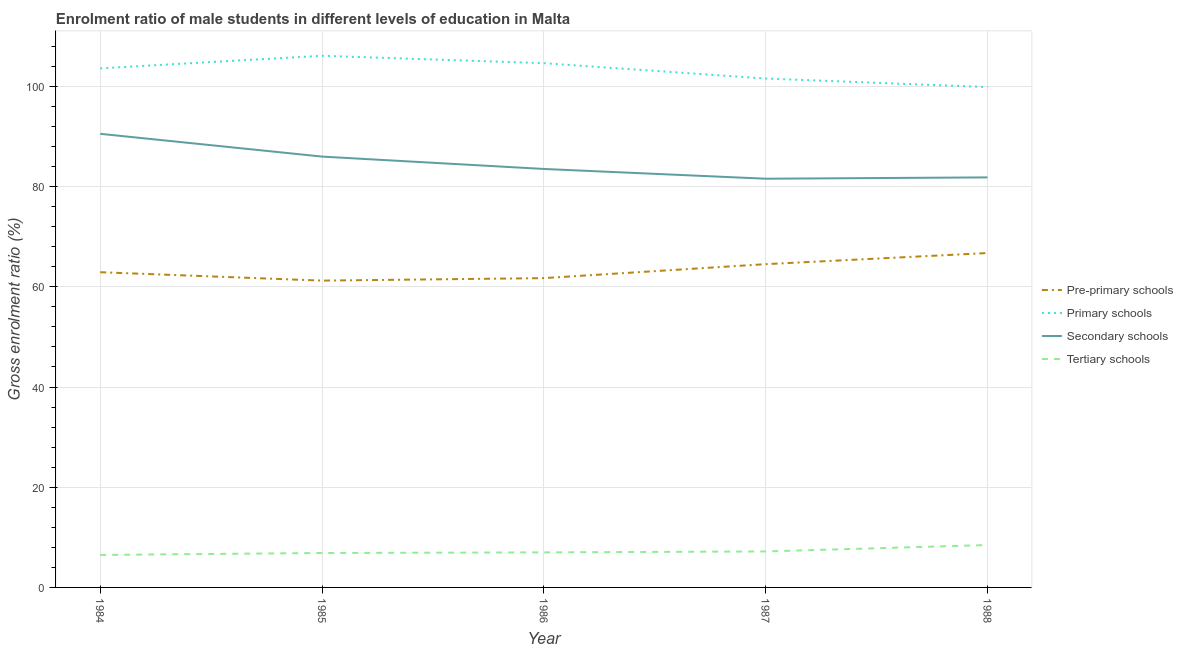How many different coloured lines are there?
Give a very brief answer. 4. Is the number of lines equal to the number of legend labels?
Give a very brief answer. Yes. What is the gross enrolment ratio(female) in pre-primary schools in 1986?
Offer a terse response. 61.73. Across all years, what is the maximum gross enrolment ratio(female) in primary schools?
Provide a succinct answer. 106.1. Across all years, what is the minimum gross enrolment ratio(female) in primary schools?
Give a very brief answer. 99.86. In which year was the gross enrolment ratio(female) in tertiary schools maximum?
Your answer should be very brief. 1988. What is the total gross enrolment ratio(female) in primary schools in the graph?
Ensure brevity in your answer.  515.75. What is the difference between the gross enrolment ratio(female) in pre-primary schools in 1986 and that in 1987?
Offer a very short reply. -2.79. What is the difference between the gross enrolment ratio(female) in tertiary schools in 1985 and the gross enrolment ratio(female) in secondary schools in 1987?
Keep it short and to the point. -74.7. What is the average gross enrolment ratio(female) in pre-primary schools per year?
Provide a short and direct response. 63.43. In the year 1986, what is the difference between the gross enrolment ratio(female) in secondary schools and gross enrolment ratio(female) in tertiary schools?
Offer a very short reply. 76.52. In how many years, is the gross enrolment ratio(female) in secondary schools greater than 4 %?
Ensure brevity in your answer.  5. What is the ratio of the gross enrolment ratio(female) in tertiary schools in 1986 to that in 1987?
Keep it short and to the point. 0.97. Is the gross enrolment ratio(female) in primary schools in 1984 less than that in 1986?
Your answer should be very brief. Yes. Is the difference between the gross enrolment ratio(female) in primary schools in 1986 and 1987 greater than the difference between the gross enrolment ratio(female) in secondary schools in 1986 and 1987?
Your answer should be compact. Yes. What is the difference between the highest and the second highest gross enrolment ratio(female) in primary schools?
Your answer should be compact. 1.48. What is the difference between the highest and the lowest gross enrolment ratio(female) in pre-primary schools?
Offer a terse response. 5.51. Is it the case that in every year, the sum of the gross enrolment ratio(female) in tertiary schools and gross enrolment ratio(female) in secondary schools is greater than the sum of gross enrolment ratio(female) in primary schools and gross enrolment ratio(female) in pre-primary schools?
Offer a terse response. No. Is it the case that in every year, the sum of the gross enrolment ratio(female) in pre-primary schools and gross enrolment ratio(female) in primary schools is greater than the gross enrolment ratio(female) in secondary schools?
Your answer should be very brief. Yes. Does the gross enrolment ratio(female) in tertiary schools monotonically increase over the years?
Provide a succinct answer. Yes. Is the gross enrolment ratio(female) in pre-primary schools strictly less than the gross enrolment ratio(female) in primary schools over the years?
Provide a succinct answer. Yes. How many lines are there?
Make the answer very short. 4. How many years are there in the graph?
Provide a short and direct response. 5. Does the graph contain any zero values?
Your response must be concise. No. Does the graph contain grids?
Ensure brevity in your answer.  Yes. Where does the legend appear in the graph?
Give a very brief answer. Center right. How are the legend labels stacked?
Your answer should be very brief. Vertical. What is the title of the graph?
Give a very brief answer. Enrolment ratio of male students in different levels of education in Malta. Does "Management rating" appear as one of the legend labels in the graph?
Ensure brevity in your answer.  No. What is the label or title of the Y-axis?
Make the answer very short. Gross enrolment ratio (%). What is the Gross enrolment ratio (%) in Pre-primary schools in 1984?
Your answer should be compact. 62.91. What is the Gross enrolment ratio (%) of Primary schools in 1984?
Keep it short and to the point. 103.6. What is the Gross enrolment ratio (%) of Secondary schools in 1984?
Offer a terse response. 90.53. What is the Gross enrolment ratio (%) of Tertiary schools in 1984?
Your response must be concise. 6.48. What is the Gross enrolment ratio (%) in Pre-primary schools in 1985?
Provide a succinct answer. 61.23. What is the Gross enrolment ratio (%) in Primary schools in 1985?
Keep it short and to the point. 106.1. What is the Gross enrolment ratio (%) in Secondary schools in 1985?
Offer a very short reply. 85.99. What is the Gross enrolment ratio (%) of Tertiary schools in 1985?
Provide a succinct answer. 6.87. What is the Gross enrolment ratio (%) of Pre-primary schools in 1986?
Ensure brevity in your answer.  61.73. What is the Gross enrolment ratio (%) in Primary schools in 1986?
Offer a terse response. 104.63. What is the Gross enrolment ratio (%) of Secondary schools in 1986?
Offer a very short reply. 83.52. What is the Gross enrolment ratio (%) of Tertiary schools in 1986?
Offer a terse response. 6.99. What is the Gross enrolment ratio (%) in Pre-primary schools in 1987?
Keep it short and to the point. 64.52. What is the Gross enrolment ratio (%) of Primary schools in 1987?
Provide a succinct answer. 101.56. What is the Gross enrolment ratio (%) of Secondary schools in 1987?
Keep it short and to the point. 81.57. What is the Gross enrolment ratio (%) of Tertiary schools in 1987?
Keep it short and to the point. 7.18. What is the Gross enrolment ratio (%) of Pre-primary schools in 1988?
Provide a succinct answer. 66.74. What is the Gross enrolment ratio (%) of Primary schools in 1988?
Give a very brief answer. 99.86. What is the Gross enrolment ratio (%) of Secondary schools in 1988?
Make the answer very short. 81.83. What is the Gross enrolment ratio (%) of Tertiary schools in 1988?
Your response must be concise. 8.46. Across all years, what is the maximum Gross enrolment ratio (%) of Pre-primary schools?
Keep it short and to the point. 66.74. Across all years, what is the maximum Gross enrolment ratio (%) of Primary schools?
Ensure brevity in your answer.  106.1. Across all years, what is the maximum Gross enrolment ratio (%) of Secondary schools?
Give a very brief answer. 90.53. Across all years, what is the maximum Gross enrolment ratio (%) of Tertiary schools?
Keep it short and to the point. 8.46. Across all years, what is the minimum Gross enrolment ratio (%) of Pre-primary schools?
Provide a succinct answer. 61.23. Across all years, what is the minimum Gross enrolment ratio (%) of Primary schools?
Your answer should be compact. 99.86. Across all years, what is the minimum Gross enrolment ratio (%) of Secondary schools?
Your answer should be very brief. 81.57. Across all years, what is the minimum Gross enrolment ratio (%) in Tertiary schools?
Keep it short and to the point. 6.48. What is the total Gross enrolment ratio (%) of Pre-primary schools in the graph?
Your answer should be very brief. 317.13. What is the total Gross enrolment ratio (%) in Primary schools in the graph?
Offer a terse response. 515.75. What is the total Gross enrolment ratio (%) of Secondary schools in the graph?
Give a very brief answer. 423.43. What is the total Gross enrolment ratio (%) in Tertiary schools in the graph?
Your answer should be very brief. 36. What is the difference between the Gross enrolment ratio (%) of Pre-primary schools in 1984 and that in 1985?
Your answer should be very brief. 1.68. What is the difference between the Gross enrolment ratio (%) in Primary schools in 1984 and that in 1985?
Offer a very short reply. -2.51. What is the difference between the Gross enrolment ratio (%) in Secondary schools in 1984 and that in 1985?
Offer a very short reply. 4.54. What is the difference between the Gross enrolment ratio (%) in Tertiary schools in 1984 and that in 1985?
Ensure brevity in your answer.  -0.39. What is the difference between the Gross enrolment ratio (%) of Pre-primary schools in 1984 and that in 1986?
Make the answer very short. 1.18. What is the difference between the Gross enrolment ratio (%) of Primary schools in 1984 and that in 1986?
Offer a terse response. -1.03. What is the difference between the Gross enrolment ratio (%) in Secondary schools in 1984 and that in 1986?
Offer a terse response. 7.01. What is the difference between the Gross enrolment ratio (%) of Tertiary schools in 1984 and that in 1986?
Your response must be concise. -0.51. What is the difference between the Gross enrolment ratio (%) in Pre-primary schools in 1984 and that in 1987?
Your response must be concise. -1.61. What is the difference between the Gross enrolment ratio (%) of Primary schools in 1984 and that in 1987?
Your answer should be compact. 2.04. What is the difference between the Gross enrolment ratio (%) in Secondary schools in 1984 and that in 1987?
Your answer should be very brief. 8.96. What is the difference between the Gross enrolment ratio (%) in Tertiary schools in 1984 and that in 1987?
Give a very brief answer. -0.7. What is the difference between the Gross enrolment ratio (%) in Pre-primary schools in 1984 and that in 1988?
Give a very brief answer. -3.83. What is the difference between the Gross enrolment ratio (%) in Primary schools in 1984 and that in 1988?
Your response must be concise. 3.74. What is the difference between the Gross enrolment ratio (%) in Secondary schools in 1984 and that in 1988?
Give a very brief answer. 8.7. What is the difference between the Gross enrolment ratio (%) of Tertiary schools in 1984 and that in 1988?
Your answer should be compact. -1.98. What is the difference between the Gross enrolment ratio (%) in Pre-primary schools in 1985 and that in 1986?
Provide a short and direct response. -0.5. What is the difference between the Gross enrolment ratio (%) in Primary schools in 1985 and that in 1986?
Ensure brevity in your answer.  1.48. What is the difference between the Gross enrolment ratio (%) in Secondary schools in 1985 and that in 1986?
Keep it short and to the point. 2.47. What is the difference between the Gross enrolment ratio (%) in Tertiary schools in 1985 and that in 1986?
Your answer should be very brief. -0.12. What is the difference between the Gross enrolment ratio (%) in Pre-primary schools in 1985 and that in 1987?
Ensure brevity in your answer.  -3.28. What is the difference between the Gross enrolment ratio (%) in Primary schools in 1985 and that in 1987?
Offer a very short reply. 4.54. What is the difference between the Gross enrolment ratio (%) in Secondary schools in 1985 and that in 1987?
Ensure brevity in your answer.  4.42. What is the difference between the Gross enrolment ratio (%) of Tertiary schools in 1985 and that in 1987?
Ensure brevity in your answer.  -0.31. What is the difference between the Gross enrolment ratio (%) in Pre-primary schools in 1985 and that in 1988?
Offer a terse response. -5.51. What is the difference between the Gross enrolment ratio (%) in Primary schools in 1985 and that in 1988?
Offer a terse response. 6.24. What is the difference between the Gross enrolment ratio (%) in Secondary schools in 1985 and that in 1988?
Make the answer very short. 4.15. What is the difference between the Gross enrolment ratio (%) in Tertiary schools in 1985 and that in 1988?
Ensure brevity in your answer.  -1.59. What is the difference between the Gross enrolment ratio (%) of Pre-primary schools in 1986 and that in 1987?
Provide a short and direct response. -2.79. What is the difference between the Gross enrolment ratio (%) in Primary schools in 1986 and that in 1987?
Keep it short and to the point. 3.07. What is the difference between the Gross enrolment ratio (%) in Secondary schools in 1986 and that in 1987?
Your answer should be very brief. 1.95. What is the difference between the Gross enrolment ratio (%) in Tertiary schools in 1986 and that in 1987?
Ensure brevity in your answer.  -0.19. What is the difference between the Gross enrolment ratio (%) of Pre-primary schools in 1986 and that in 1988?
Your response must be concise. -5.01. What is the difference between the Gross enrolment ratio (%) of Primary schools in 1986 and that in 1988?
Your answer should be very brief. 4.77. What is the difference between the Gross enrolment ratio (%) in Secondary schools in 1986 and that in 1988?
Offer a very short reply. 1.68. What is the difference between the Gross enrolment ratio (%) of Tertiary schools in 1986 and that in 1988?
Offer a very short reply. -1.47. What is the difference between the Gross enrolment ratio (%) of Pre-primary schools in 1987 and that in 1988?
Your answer should be very brief. -2.22. What is the difference between the Gross enrolment ratio (%) of Primary schools in 1987 and that in 1988?
Provide a short and direct response. 1.7. What is the difference between the Gross enrolment ratio (%) in Secondary schools in 1987 and that in 1988?
Keep it short and to the point. -0.26. What is the difference between the Gross enrolment ratio (%) of Tertiary schools in 1987 and that in 1988?
Offer a terse response. -1.28. What is the difference between the Gross enrolment ratio (%) of Pre-primary schools in 1984 and the Gross enrolment ratio (%) of Primary schools in 1985?
Ensure brevity in your answer.  -43.19. What is the difference between the Gross enrolment ratio (%) of Pre-primary schools in 1984 and the Gross enrolment ratio (%) of Secondary schools in 1985?
Offer a very short reply. -23.08. What is the difference between the Gross enrolment ratio (%) in Pre-primary schools in 1984 and the Gross enrolment ratio (%) in Tertiary schools in 1985?
Offer a terse response. 56.04. What is the difference between the Gross enrolment ratio (%) in Primary schools in 1984 and the Gross enrolment ratio (%) in Secondary schools in 1985?
Offer a very short reply. 17.61. What is the difference between the Gross enrolment ratio (%) in Primary schools in 1984 and the Gross enrolment ratio (%) in Tertiary schools in 1985?
Provide a succinct answer. 96.72. What is the difference between the Gross enrolment ratio (%) in Secondary schools in 1984 and the Gross enrolment ratio (%) in Tertiary schools in 1985?
Ensure brevity in your answer.  83.66. What is the difference between the Gross enrolment ratio (%) of Pre-primary schools in 1984 and the Gross enrolment ratio (%) of Primary schools in 1986?
Make the answer very short. -41.72. What is the difference between the Gross enrolment ratio (%) in Pre-primary schools in 1984 and the Gross enrolment ratio (%) in Secondary schools in 1986?
Provide a short and direct response. -20.61. What is the difference between the Gross enrolment ratio (%) of Pre-primary schools in 1984 and the Gross enrolment ratio (%) of Tertiary schools in 1986?
Offer a terse response. 55.91. What is the difference between the Gross enrolment ratio (%) in Primary schools in 1984 and the Gross enrolment ratio (%) in Secondary schools in 1986?
Give a very brief answer. 20.08. What is the difference between the Gross enrolment ratio (%) of Primary schools in 1984 and the Gross enrolment ratio (%) of Tertiary schools in 1986?
Your response must be concise. 96.6. What is the difference between the Gross enrolment ratio (%) in Secondary schools in 1984 and the Gross enrolment ratio (%) in Tertiary schools in 1986?
Give a very brief answer. 83.54. What is the difference between the Gross enrolment ratio (%) of Pre-primary schools in 1984 and the Gross enrolment ratio (%) of Primary schools in 1987?
Give a very brief answer. -38.65. What is the difference between the Gross enrolment ratio (%) of Pre-primary schools in 1984 and the Gross enrolment ratio (%) of Secondary schools in 1987?
Offer a very short reply. -18.66. What is the difference between the Gross enrolment ratio (%) of Pre-primary schools in 1984 and the Gross enrolment ratio (%) of Tertiary schools in 1987?
Provide a short and direct response. 55.73. What is the difference between the Gross enrolment ratio (%) in Primary schools in 1984 and the Gross enrolment ratio (%) in Secondary schools in 1987?
Provide a succinct answer. 22.03. What is the difference between the Gross enrolment ratio (%) of Primary schools in 1984 and the Gross enrolment ratio (%) of Tertiary schools in 1987?
Ensure brevity in your answer.  96.42. What is the difference between the Gross enrolment ratio (%) in Secondary schools in 1984 and the Gross enrolment ratio (%) in Tertiary schools in 1987?
Ensure brevity in your answer.  83.35. What is the difference between the Gross enrolment ratio (%) of Pre-primary schools in 1984 and the Gross enrolment ratio (%) of Primary schools in 1988?
Offer a very short reply. -36.95. What is the difference between the Gross enrolment ratio (%) in Pre-primary schools in 1984 and the Gross enrolment ratio (%) in Secondary schools in 1988?
Make the answer very short. -18.93. What is the difference between the Gross enrolment ratio (%) in Pre-primary schools in 1984 and the Gross enrolment ratio (%) in Tertiary schools in 1988?
Provide a succinct answer. 54.45. What is the difference between the Gross enrolment ratio (%) in Primary schools in 1984 and the Gross enrolment ratio (%) in Secondary schools in 1988?
Ensure brevity in your answer.  21.76. What is the difference between the Gross enrolment ratio (%) in Primary schools in 1984 and the Gross enrolment ratio (%) in Tertiary schools in 1988?
Your answer should be compact. 95.14. What is the difference between the Gross enrolment ratio (%) in Secondary schools in 1984 and the Gross enrolment ratio (%) in Tertiary schools in 1988?
Provide a succinct answer. 82.07. What is the difference between the Gross enrolment ratio (%) of Pre-primary schools in 1985 and the Gross enrolment ratio (%) of Primary schools in 1986?
Keep it short and to the point. -43.39. What is the difference between the Gross enrolment ratio (%) in Pre-primary schools in 1985 and the Gross enrolment ratio (%) in Secondary schools in 1986?
Your response must be concise. -22.28. What is the difference between the Gross enrolment ratio (%) in Pre-primary schools in 1985 and the Gross enrolment ratio (%) in Tertiary schools in 1986?
Your answer should be compact. 54.24. What is the difference between the Gross enrolment ratio (%) in Primary schools in 1985 and the Gross enrolment ratio (%) in Secondary schools in 1986?
Give a very brief answer. 22.59. What is the difference between the Gross enrolment ratio (%) of Primary schools in 1985 and the Gross enrolment ratio (%) of Tertiary schools in 1986?
Provide a short and direct response. 99.11. What is the difference between the Gross enrolment ratio (%) in Secondary schools in 1985 and the Gross enrolment ratio (%) in Tertiary schools in 1986?
Ensure brevity in your answer.  78.99. What is the difference between the Gross enrolment ratio (%) of Pre-primary schools in 1985 and the Gross enrolment ratio (%) of Primary schools in 1987?
Offer a terse response. -40.33. What is the difference between the Gross enrolment ratio (%) of Pre-primary schools in 1985 and the Gross enrolment ratio (%) of Secondary schools in 1987?
Keep it short and to the point. -20.34. What is the difference between the Gross enrolment ratio (%) of Pre-primary schools in 1985 and the Gross enrolment ratio (%) of Tertiary schools in 1987?
Your answer should be compact. 54.05. What is the difference between the Gross enrolment ratio (%) in Primary schools in 1985 and the Gross enrolment ratio (%) in Secondary schools in 1987?
Give a very brief answer. 24.53. What is the difference between the Gross enrolment ratio (%) in Primary schools in 1985 and the Gross enrolment ratio (%) in Tertiary schools in 1987?
Your answer should be compact. 98.92. What is the difference between the Gross enrolment ratio (%) in Secondary schools in 1985 and the Gross enrolment ratio (%) in Tertiary schools in 1987?
Give a very brief answer. 78.8. What is the difference between the Gross enrolment ratio (%) of Pre-primary schools in 1985 and the Gross enrolment ratio (%) of Primary schools in 1988?
Offer a very short reply. -38.63. What is the difference between the Gross enrolment ratio (%) in Pre-primary schools in 1985 and the Gross enrolment ratio (%) in Secondary schools in 1988?
Offer a very short reply. -20.6. What is the difference between the Gross enrolment ratio (%) in Pre-primary schools in 1985 and the Gross enrolment ratio (%) in Tertiary schools in 1988?
Your answer should be very brief. 52.77. What is the difference between the Gross enrolment ratio (%) in Primary schools in 1985 and the Gross enrolment ratio (%) in Secondary schools in 1988?
Keep it short and to the point. 24.27. What is the difference between the Gross enrolment ratio (%) in Primary schools in 1985 and the Gross enrolment ratio (%) in Tertiary schools in 1988?
Ensure brevity in your answer.  97.64. What is the difference between the Gross enrolment ratio (%) in Secondary schools in 1985 and the Gross enrolment ratio (%) in Tertiary schools in 1988?
Keep it short and to the point. 77.52. What is the difference between the Gross enrolment ratio (%) in Pre-primary schools in 1986 and the Gross enrolment ratio (%) in Primary schools in 1987?
Provide a short and direct response. -39.83. What is the difference between the Gross enrolment ratio (%) in Pre-primary schools in 1986 and the Gross enrolment ratio (%) in Secondary schools in 1987?
Provide a short and direct response. -19.84. What is the difference between the Gross enrolment ratio (%) in Pre-primary schools in 1986 and the Gross enrolment ratio (%) in Tertiary schools in 1987?
Your answer should be compact. 54.55. What is the difference between the Gross enrolment ratio (%) in Primary schools in 1986 and the Gross enrolment ratio (%) in Secondary schools in 1987?
Ensure brevity in your answer.  23.06. What is the difference between the Gross enrolment ratio (%) of Primary schools in 1986 and the Gross enrolment ratio (%) of Tertiary schools in 1987?
Your answer should be compact. 97.44. What is the difference between the Gross enrolment ratio (%) in Secondary schools in 1986 and the Gross enrolment ratio (%) in Tertiary schools in 1987?
Make the answer very short. 76.33. What is the difference between the Gross enrolment ratio (%) of Pre-primary schools in 1986 and the Gross enrolment ratio (%) of Primary schools in 1988?
Provide a succinct answer. -38.13. What is the difference between the Gross enrolment ratio (%) of Pre-primary schools in 1986 and the Gross enrolment ratio (%) of Secondary schools in 1988?
Provide a succinct answer. -20.1. What is the difference between the Gross enrolment ratio (%) in Pre-primary schools in 1986 and the Gross enrolment ratio (%) in Tertiary schools in 1988?
Make the answer very short. 53.27. What is the difference between the Gross enrolment ratio (%) in Primary schools in 1986 and the Gross enrolment ratio (%) in Secondary schools in 1988?
Offer a very short reply. 22.79. What is the difference between the Gross enrolment ratio (%) of Primary schools in 1986 and the Gross enrolment ratio (%) of Tertiary schools in 1988?
Provide a succinct answer. 96.16. What is the difference between the Gross enrolment ratio (%) in Secondary schools in 1986 and the Gross enrolment ratio (%) in Tertiary schools in 1988?
Your answer should be compact. 75.05. What is the difference between the Gross enrolment ratio (%) of Pre-primary schools in 1987 and the Gross enrolment ratio (%) of Primary schools in 1988?
Provide a short and direct response. -35.34. What is the difference between the Gross enrolment ratio (%) in Pre-primary schools in 1987 and the Gross enrolment ratio (%) in Secondary schools in 1988?
Offer a very short reply. -17.32. What is the difference between the Gross enrolment ratio (%) of Pre-primary schools in 1987 and the Gross enrolment ratio (%) of Tertiary schools in 1988?
Provide a short and direct response. 56.06. What is the difference between the Gross enrolment ratio (%) in Primary schools in 1987 and the Gross enrolment ratio (%) in Secondary schools in 1988?
Keep it short and to the point. 19.73. What is the difference between the Gross enrolment ratio (%) in Primary schools in 1987 and the Gross enrolment ratio (%) in Tertiary schools in 1988?
Offer a very short reply. 93.1. What is the difference between the Gross enrolment ratio (%) of Secondary schools in 1987 and the Gross enrolment ratio (%) of Tertiary schools in 1988?
Your answer should be compact. 73.11. What is the average Gross enrolment ratio (%) of Pre-primary schools per year?
Make the answer very short. 63.43. What is the average Gross enrolment ratio (%) in Primary schools per year?
Offer a very short reply. 103.15. What is the average Gross enrolment ratio (%) of Secondary schools per year?
Your answer should be very brief. 84.69. What is the average Gross enrolment ratio (%) of Tertiary schools per year?
Give a very brief answer. 7.2. In the year 1984, what is the difference between the Gross enrolment ratio (%) in Pre-primary schools and Gross enrolment ratio (%) in Primary schools?
Provide a short and direct response. -40.69. In the year 1984, what is the difference between the Gross enrolment ratio (%) in Pre-primary schools and Gross enrolment ratio (%) in Secondary schools?
Offer a very short reply. -27.62. In the year 1984, what is the difference between the Gross enrolment ratio (%) of Pre-primary schools and Gross enrolment ratio (%) of Tertiary schools?
Keep it short and to the point. 56.43. In the year 1984, what is the difference between the Gross enrolment ratio (%) of Primary schools and Gross enrolment ratio (%) of Secondary schools?
Give a very brief answer. 13.07. In the year 1984, what is the difference between the Gross enrolment ratio (%) of Primary schools and Gross enrolment ratio (%) of Tertiary schools?
Give a very brief answer. 97.11. In the year 1984, what is the difference between the Gross enrolment ratio (%) of Secondary schools and Gross enrolment ratio (%) of Tertiary schools?
Offer a terse response. 84.05. In the year 1985, what is the difference between the Gross enrolment ratio (%) of Pre-primary schools and Gross enrolment ratio (%) of Primary schools?
Keep it short and to the point. -44.87. In the year 1985, what is the difference between the Gross enrolment ratio (%) of Pre-primary schools and Gross enrolment ratio (%) of Secondary schools?
Your answer should be very brief. -24.75. In the year 1985, what is the difference between the Gross enrolment ratio (%) in Pre-primary schools and Gross enrolment ratio (%) in Tertiary schools?
Ensure brevity in your answer.  54.36. In the year 1985, what is the difference between the Gross enrolment ratio (%) of Primary schools and Gross enrolment ratio (%) of Secondary schools?
Provide a short and direct response. 20.12. In the year 1985, what is the difference between the Gross enrolment ratio (%) in Primary schools and Gross enrolment ratio (%) in Tertiary schools?
Provide a succinct answer. 99.23. In the year 1985, what is the difference between the Gross enrolment ratio (%) of Secondary schools and Gross enrolment ratio (%) of Tertiary schools?
Provide a succinct answer. 79.11. In the year 1986, what is the difference between the Gross enrolment ratio (%) of Pre-primary schools and Gross enrolment ratio (%) of Primary schools?
Offer a terse response. -42.9. In the year 1986, what is the difference between the Gross enrolment ratio (%) in Pre-primary schools and Gross enrolment ratio (%) in Secondary schools?
Make the answer very short. -21.79. In the year 1986, what is the difference between the Gross enrolment ratio (%) of Pre-primary schools and Gross enrolment ratio (%) of Tertiary schools?
Offer a very short reply. 54.74. In the year 1986, what is the difference between the Gross enrolment ratio (%) of Primary schools and Gross enrolment ratio (%) of Secondary schools?
Your answer should be very brief. 21.11. In the year 1986, what is the difference between the Gross enrolment ratio (%) in Primary schools and Gross enrolment ratio (%) in Tertiary schools?
Make the answer very short. 97.63. In the year 1986, what is the difference between the Gross enrolment ratio (%) in Secondary schools and Gross enrolment ratio (%) in Tertiary schools?
Your answer should be compact. 76.52. In the year 1987, what is the difference between the Gross enrolment ratio (%) of Pre-primary schools and Gross enrolment ratio (%) of Primary schools?
Offer a very short reply. -37.04. In the year 1987, what is the difference between the Gross enrolment ratio (%) of Pre-primary schools and Gross enrolment ratio (%) of Secondary schools?
Keep it short and to the point. -17.05. In the year 1987, what is the difference between the Gross enrolment ratio (%) of Pre-primary schools and Gross enrolment ratio (%) of Tertiary schools?
Provide a succinct answer. 57.34. In the year 1987, what is the difference between the Gross enrolment ratio (%) in Primary schools and Gross enrolment ratio (%) in Secondary schools?
Provide a short and direct response. 19.99. In the year 1987, what is the difference between the Gross enrolment ratio (%) of Primary schools and Gross enrolment ratio (%) of Tertiary schools?
Provide a short and direct response. 94.38. In the year 1987, what is the difference between the Gross enrolment ratio (%) in Secondary schools and Gross enrolment ratio (%) in Tertiary schools?
Ensure brevity in your answer.  74.39. In the year 1988, what is the difference between the Gross enrolment ratio (%) of Pre-primary schools and Gross enrolment ratio (%) of Primary schools?
Ensure brevity in your answer.  -33.12. In the year 1988, what is the difference between the Gross enrolment ratio (%) in Pre-primary schools and Gross enrolment ratio (%) in Secondary schools?
Give a very brief answer. -15.1. In the year 1988, what is the difference between the Gross enrolment ratio (%) in Pre-primary schools and Gross enrolment ratio (%) in Tertiary schools?
Provide a short and direct response. 58.28. In the year 1988, what is the difference between the Gross enrolment ratio (%) in Primary schools and Gross enrolment ratio (%) in Secondary schools?
Your response must be concise. 18.03. In the year 1988, what is the difference between the Gross enrolment ratio (%) in Primary schools and Gross enrolment ratio (%) in Tertiary schools?
Provide a short and direct response. 91.4. In the year 1988, what is the difference between the Gross enrolment ratio (%) in Secondary schools and Gross enrolment ratio (%) in Tertiary schools?
Offer a terse response. 73.37. What is the ratio of the Gross enrolment ratio (%) in Pre-primary schools in 1984 to that in 1985?
Your answer should be compact. 1.03. What is the ratio of the Gross enrolment ratio (%) of Primary schools in 1984 to that in 1985?
Ensure brevity in your answer.  0.98. What is the ratio of the Gross enrolment ratio (%) of Secondary schools in 1984 to that in 1985?
Provide a short and direct response. 1.05. What is the ratio of the Gross enrolment ratio (%) of Tertiary schools in 1984 to that in 1985?
Make the answer very short. 0.94. What is the ratio of the Gross enrolment ratio (%) in Pre-primary schools in 1984 to that in 1986?
Your answer should be compact. 1.02. What is the ratio of the Gross enrolment ratio (%) in Primary schools in 1984 to that in 1986?
Your answer should be compact. 0.99. What is the ratio of the Gross enrolment ratio (%) of Secondary schools in 1984 to that in 1986?
Ensure brevity in your answer.  1.08. What is the ratio of the Gross enrolment ratio (%) of Tertiary schools in 1984 to that in 1986?
Offer a terse response. 0.93. What is the ratio of the Gross enrolment ratio (%) of Pre-primary schools in 1984 to that in 1987?
Offer a very short reply. 0.98. What is the ratio of the Gross enrolment ratio (%) in Primary schools in 1984 to that in 1987?
Provide a short and direct response. 1.02. What is the ratio of the Gross enrolment ratio (%) of Secondary schools in 1984 to that in 1987?
Offer a very short reply. 1.11. What is the ratio of the Gross enrolment ratio (%) of Tertiary schools in 1984 to that in 1987?
Make the answer very short. 0.9. What is the ratio of the Gross enrolment ratio (%) of Pre-primary schools in 1984 to that in 1988?
Ensure brevity in your answer.  0.94. What is the ratio of the Gross enrolment ratio (%) in Primary schools in 1984 to that in 1988?
Keep it short and to the point. 1.04. What is the ratio of the Gross enrolment ratio (%) in Secondary schools in 1984 to that in 1988?
Provide a short and direct response. 1.11. What is the ratio of the Gross enrolment ratio (%) in Tertiary schools in 1984 to that in 1988?
Provide a succinct answer. 0.77. What is the ratio of the Gross enrolment ratio (%) in Primary schools in 1985 to that in 1986?
Offer a very short reply. 1.01. What is the ratio of the Gross enrolment ratio (%) of Secondary schools in 1985 to that in 1986?
Keep it short and to the point. 1.03. What is the ratio of the Gross enrolment ratio (%) in Tertiary schools in 1985 to that in 1986?
Your answer should be compact. 0.98. What is the ratio of the Gross enrolment ratio (%) of Pre-primary schools in 1985 to that in 1987?
Provide a succinct answer. 0.95. What is the ratio of the Gross enrolment ratio (%) of Primary schools in 1985 to that in 1987?
Offer a terse response. 1.04. What is the ratio of the Gross enrolment ratio (%) in Secondary schools in 1985 to that in 1987?
Provide a succinct answer. 1.05. What is the ratio of the Gross enrolment ratio (%) in Tertiary schools in 1985 to that in 1987?
Ensure brevity in your answer.  0.96. What is the ratio of the Gross enrolment ratio (%) of Pre-primary schools in 1985 to that in 1988?
Your answer should be very brief. 0.92. What is the ratio of the Gross enrolment ratio (%) in Secondary schools in 1985 to that in 1988?
Your answer should be very brief. 1.05. What is the ratio of the Gross enrolment ratio (%) in Tertiary schools in 1985 to that in 1988?
Make the answer very short. 0.81. What is the ratio of the Gross enrolment ratio (%) of Pre-primary schools in 1986 to that in 1987?
Offer a terse response. 0.96. What is the ratio of the Gross enrolment ratio (%) in Primary schools in 1986 to that in 1987?
Ensure brevity in your answer.  1.03. What is the ratio of the Gross enrolment ratio (%) of Secondary schools in 1986 to that in 1987?
Give a very brief answer. 1.02. What is the ratio of the Gross enrolment ratio (%) in Tertiary schools in 1986 to that in 1987?
Keep it short and to the point. 0.97. What is the ratio of the Gross enrolment ratio (%) of Pre-primary schools in 1986 to that in 1988?
Offer a very short reply. 0.93. What is the ratio of the Gross enrolment ratio (%) of Primary schools in 1986 to that in 1988?
Your answer should be compact. 1.05. What is the ratio of the Gross enrolment ratio (%) in Secondary schools in 1986 to that in 1988?
Make the answer very short. 1.02. What is the ratio of the Gross enrolment ratio (%) in Tertiary schools in 1986 to that in 1988?
Give a very brief answer. 0.83. What is the ratio of the Gross enrolment ratio (%) of Pre-primary schools in 1987 to that in 1988?
Give a very brief answer. 0.97. What is the ratio of the Gross enrolment ratio (%) of Secondary schools in 1987 to that in 1988?
Provide a short and direct response. 1. What is the ratio of the Gross enrolment ratio (%) of Tertiary schools in 1987 to that in 1988?
Make the answer very short. 0.85. What is the difference between the highest and the second highest Gross enrolment ratio (%) of Pre-primary schools?
Your answer should be compact. 2.22. What is the difference between the highest and the second highest Gross enrolment ratio (%) in Primary schools?
Offer a terse response. 1.48. What is the difference between the highest and the second highest Gross enrolment ratio (%) in Secondary schools?
Offer a terse response. 4.54. What is the difference between the highest and the second highest Gross enrolment ratio (%) of Tertiary schools?
Your answer should be compact. 1.28. What is the difference between the highest and the lowest Gross enrolment ratio (%) in Pre-primary schools?
Make the answer very short. 5.51. What is the difference between the highest and the lowest Gross enrolment ratio (%) of Primary schools?
Offer a terse response. 6.24. What is the difference between the highest and the lowest Gross enrolment ratio (%) in Secondary schools?
Your response must be concise. 8.96. What is the difference between the highest and the lowest Gross enrolment ratio (%) of Tertiary schools?
Ensure brevity in your answer.  1.98. 